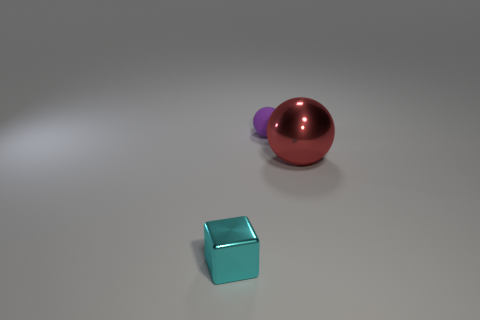Are there fewer tiny things behind the tiny block than cyan shiny objects? Actually, from this perspective, we can see one cyan shiny cube in the foreground, and no objects are visible behind it. Therefore, there are not fewer tiny things behind the tiny block than there are cyan shiny objects, because the number of tiny things behind the cube is zero. 